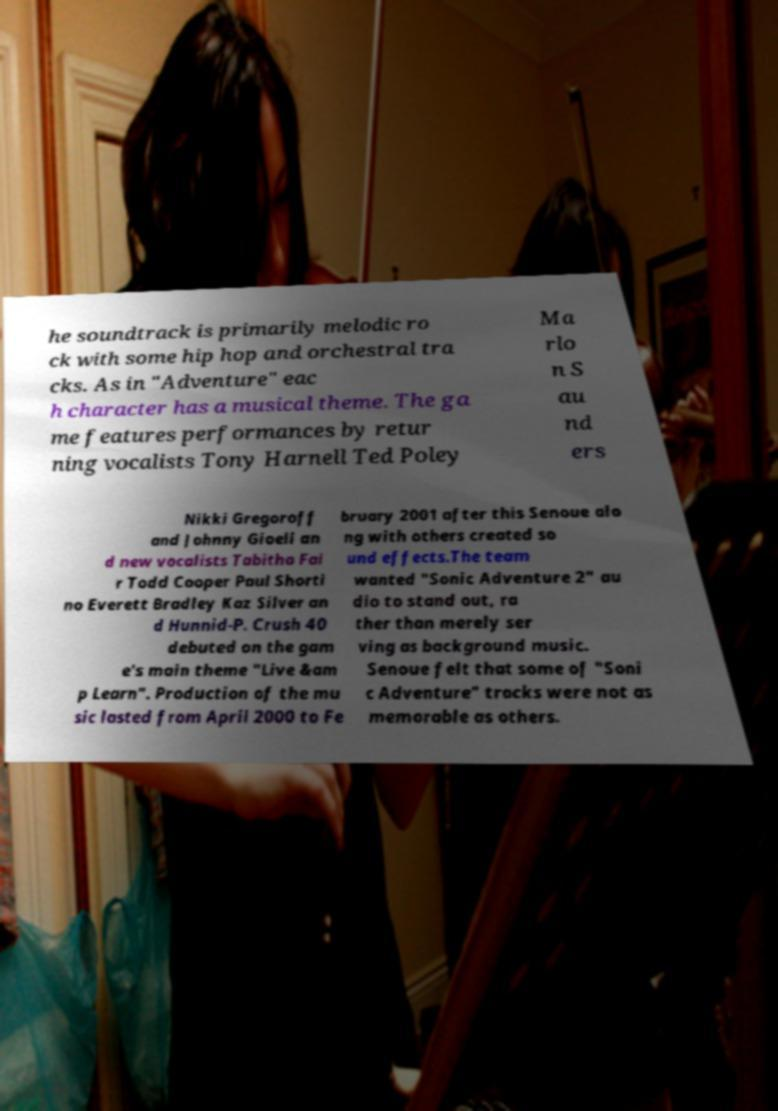Could you assist in decoding the text presented in this image and type it out clearly? he soundtrack is primarily melodic ro ck with some hip hop and orchestral tra cks. As in "Adventure" eac h character has a musical theme. The ga me features performances by retur ning vocalists Tony Harnell Ted Poley Ma rlo n S au nd ers Nikki Gregoroff and Johnny Gioeli an d new vocalists Tabitha Fai r Todd Cooper Paul Shorti no Everett Bradley Kaz Silver an d Hunnid-P. Crush 40 debuted on the gam e's main theme "Live &am p Learn". Production of the mu sic lasted from April 2000 to Fe bruary 2001 after this Senoue alo ng with others created so und effects.The team wanted "Sonic Adventure 2" au dio to stand out, ra ther than merely ser ving as background music. Senoue felt that some of "Soni c Adventure" tracks were not as memorable as others. 